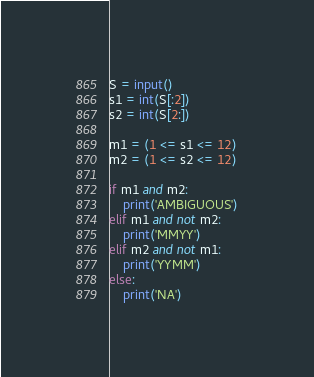<code> <loc_0><loc_0><loc_500><loc_500><_Python_>S = input()
s1 = int(S[:2])
s2 = int(S[2:])

m1 = (1 <= s1 <= 12)
m2 = (1 <= s2 <= 12)

if m1 and m2:
    print('AMBIGUOUS')
elif m1 and not m2:
    print('MMYY')
elif m2 and not m1:
    print('YYMM')
else:
    print('NA')

</code> 